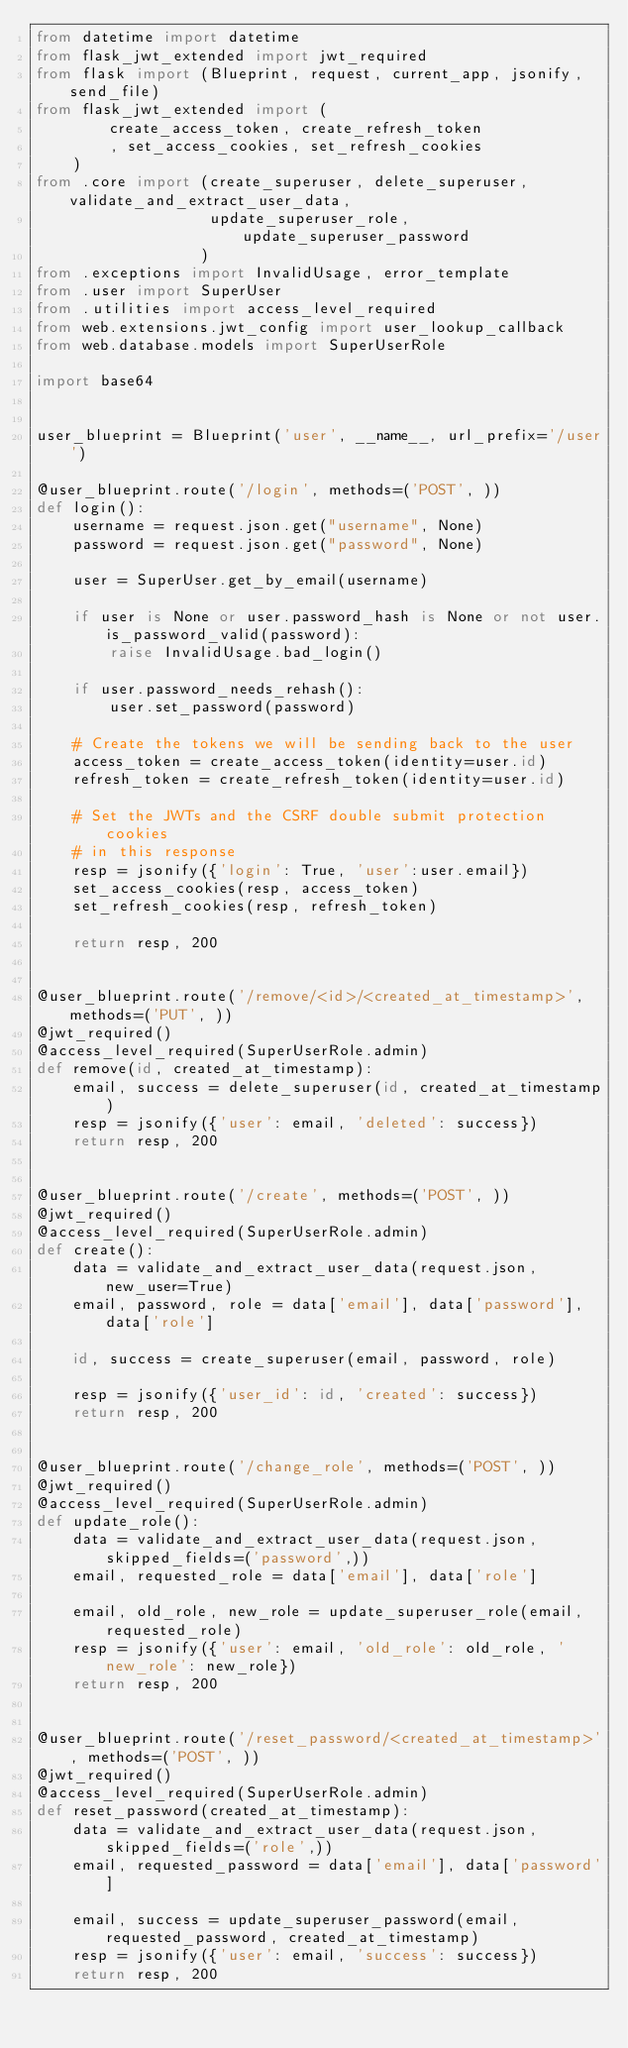<code> <loc_0><loc_0><loc_500><loc_500><_Python_>from datetime import datetime
from flask_jwt_extended import jwt_required
from flask import (Blueprint, request, current_app, jsonify, send_file)
from flask_jwt_extended import (
        create_access_token, create_refresh_token
        , set_access_cookies, set_refresh_cookies
    )
from .core import (create_superuser, delete_superuser, validate_and_extract_user_data,
                   update_superuser_role, update_superuser_password
                  )
from .exceptions import InvalidUsage, error_template
from .user import SuperUser
from .utilities import access_level_required
from web.extensions.jwt_config import user_lookup_callback
from web.database.models import SuperUserRole

import base64


user_blueprint = Blueprint('user', __name__, url_prefix='/user')

@user_blueprint.route('/login', methods=('POST', ))
def login():
    username = request.json.get("username", None)
    password = request.json.get("password", None)

    user = SuperUser.get_by_email(username)
    
    if user is None or user.password_hash is None or not user.is_password_valid(password):
        raise InvalidUsage.bad_login()

    if user.password_needs_rehash():
        user.set_password(password)

    # Create the tokens we will be sending back to the user
    access_token = create_access_token(identity=user.id)
    refresh_token = create_refresh_token(identity=user.id)

    # Set the JWTs and the CSRF double submit protection cookies
    # in this response
    resp = jsonify({'login': True, 'user':user.email})
    set_access_cookies(resp, access_token)
    set_refresh_cookies(resp, refresh_token)

    return resp, 200


@user_blueprint.route('/remove/<id>/<created_at_timestamp>', methods=('PUT', ))
@jwt_required()
@access_level_required(SuperUserRole.admin)
def remove(id, created_at_timestamp):
    email, success = delete_superuser(id, created_at_timestamp)
    resp = jsonify({'user': email, 'deleted': success})
    return resp, 200


@user_blueprint.route('/create', methods=('POST', ))
@jwt_required()
@access_level_required(SuperUserRole.admin)
def create():
    data = validate_and_extract_user_data(request.json, new_user=True)
    email, password, role = data['email'], data['password'], data['role']

    id, success = create_superuser(email, password, role)

    resp = jsonify({'user_id': id, 'created': success})
    return resp, 200


@user_blueprint.route('/change_role', methods=('POST', ))
@jwt_required()
@access_level_required(SuperUserRole.admin)
def update_role():
    data = validate_and_extract_user_data(request.json, skipped_fields=('password',))
    email, requested_role = data['email'], data['role']

    email, old_role, new_role = update_superuser_role(email, requested_role)
    resp = jsonify({'user': email, 'old_role': old_role, 'new_role': new_role})
    return resp, 200


@user_blueprint.route('/reset_password/<created_at_timestamp>', methods=('POST', ))
@jwt_required()
@access_level_required(SuperUserRole.admin)
def reset_password(created_at_timestamp):
    data = validate_and_extract_user_data(request.json, skipped_fields=('role',))
    email, requested_password = data['email'], data['password']

    email, success = update_superuser_password(email, requested_password, created_at_timestamp)
    resp = jsonify({'user': email, 'success': success})
    return resp, 200</code> 